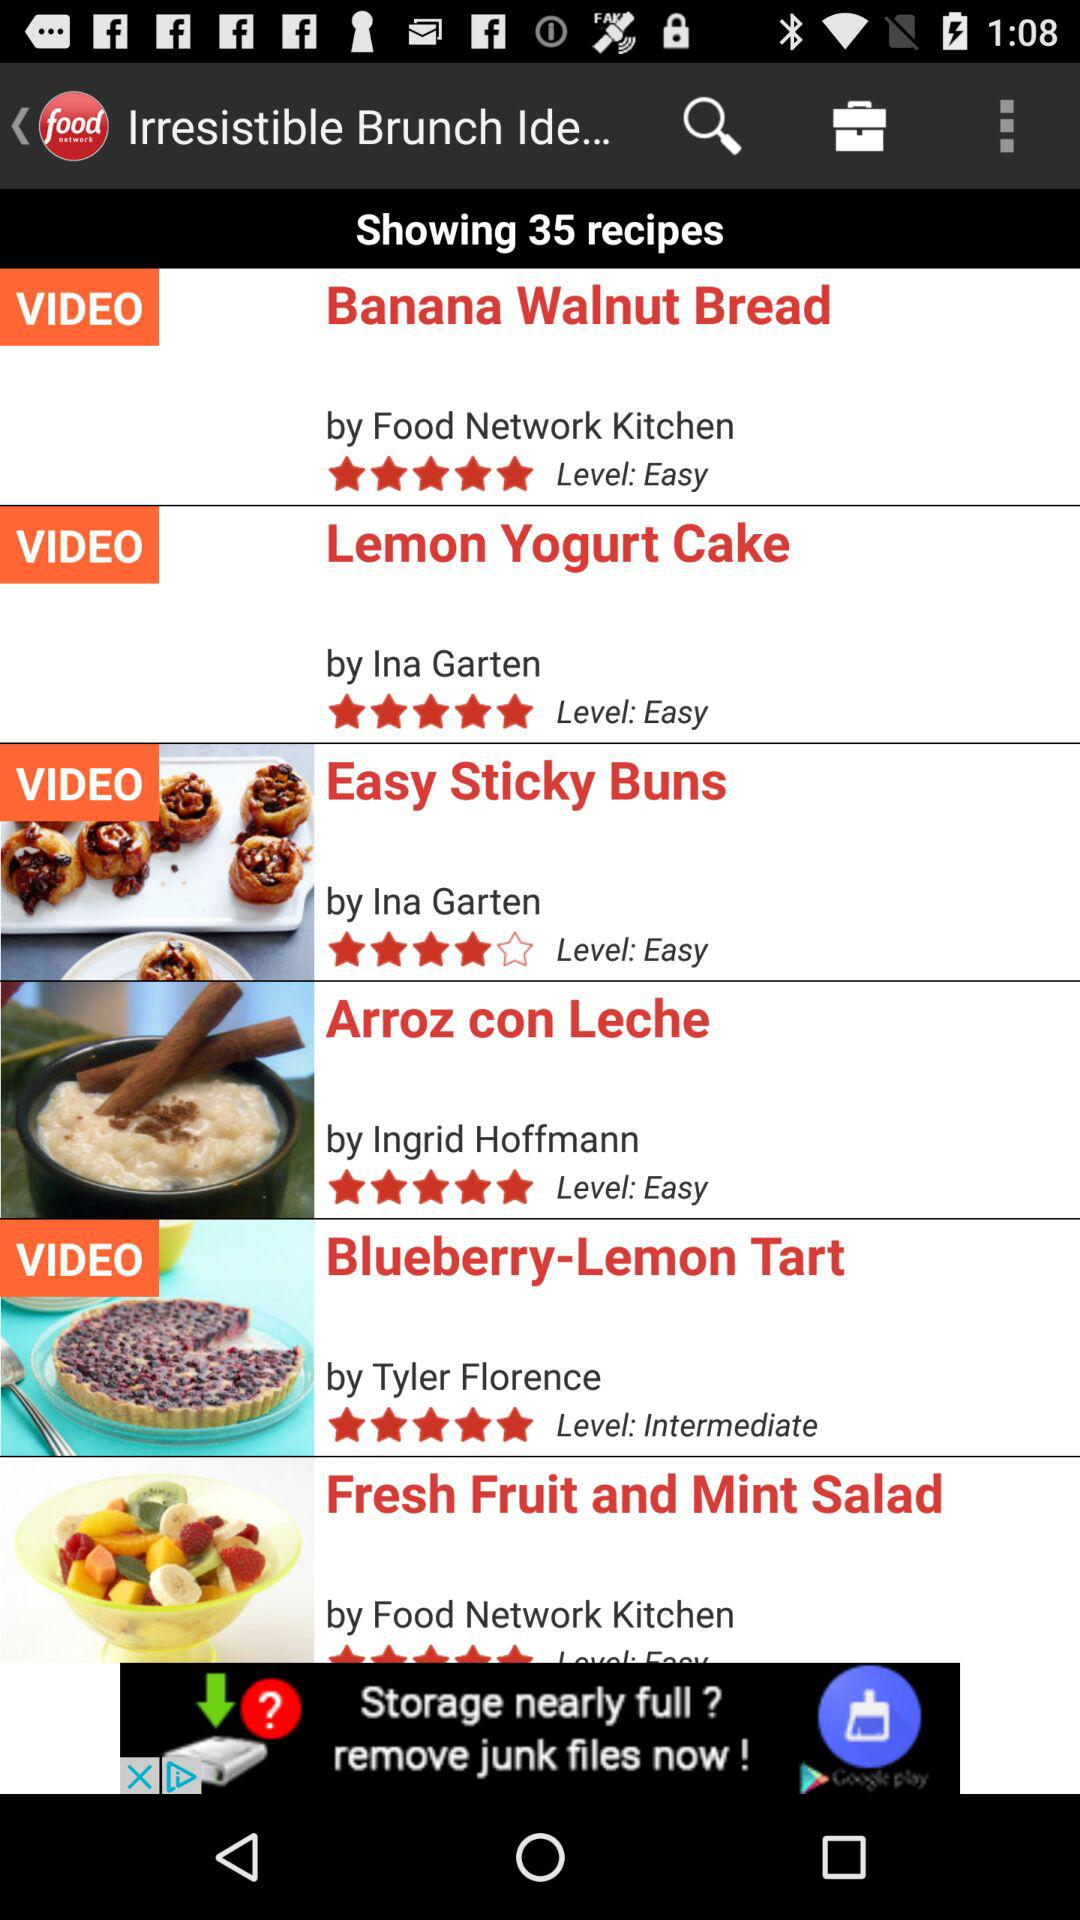What is the name of the application? The application name is Food Network. 